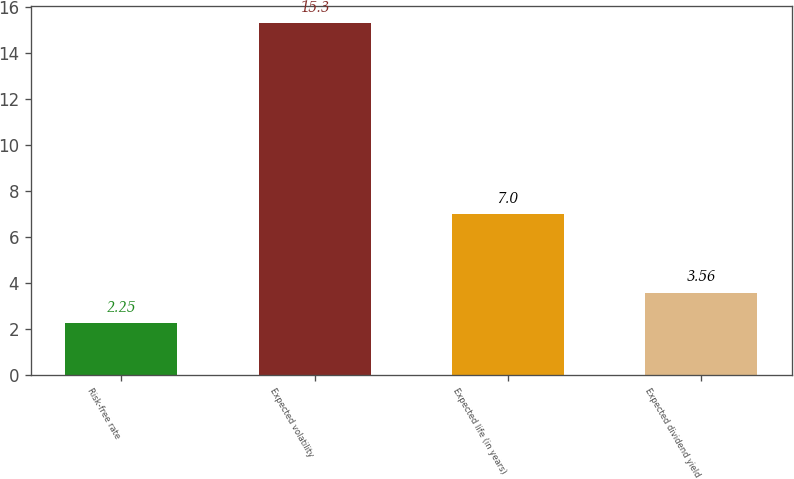<chart> <loc_0><loc_0><loc_500><loc_500><bar_chart><fcel>Risk-free rate<fcel>Expected volatility<fcel>Expected life (in years)<fcel>Expected dividend yield<nl><fcel>2.25<fcel>15.3<fcel>7<fcel>3.56<nl></chart> 